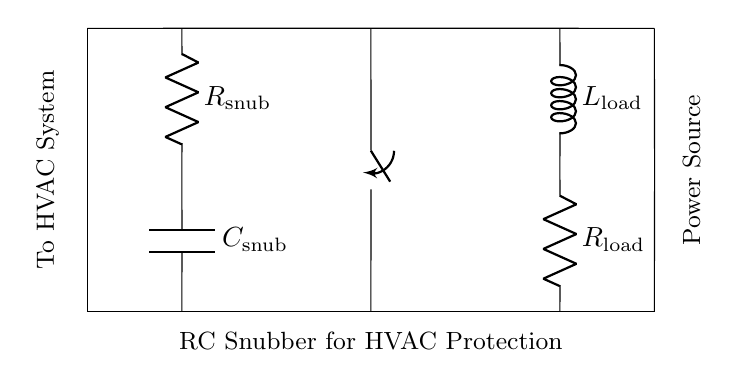What components are present in this circuit? The circuit includes a resistor labeled Rsnub, a capacitor labeled Csnub, an inductor labeled Lload, and another resistor labeled Rload, as shown in the diagram.
Answer: resistor, capacitor, inductor What is the purpose of the snubber circuit in this diagram? The snubber circuit is designed to protect the HVAC system from voltage spikes by dissipating the energy and preventing damage to sensitive components.
Answer: protection What is the placement of the switch in the circuit? The switch is placed in series with the snubber and load components, allowing control over the connection of the load to the power source and the snubber circuit when switched.
Answer: series with snubber and load How is the capacitor connected in this circuit? The capacitor is connected in parallel to the load resistor, providing a path for transient currents that can arise during operation and protecting against voltage spikes.
Answer: parallel to load resistor What is the effect of the RC snubber on voltage spikes? The snubber absorbs and dissipates energy from voltage spikes, thereby reducing the peak voltage that reaches the load.
Answer: reduce peak voltage What happens when the switch is open in this circuit? When the switch is open, the load is disconnected from the circuit, preventing current from flowing through the load and thereby isolating it from any surges or spikes.
Answer: current stops flowing What kind of load is represented by Lload in this circuit? The load represented by Lload can be understood generally as an inductive component, which could be used in various applications like motors or inductive heating in an HVAC system.
Answer: inductive load 